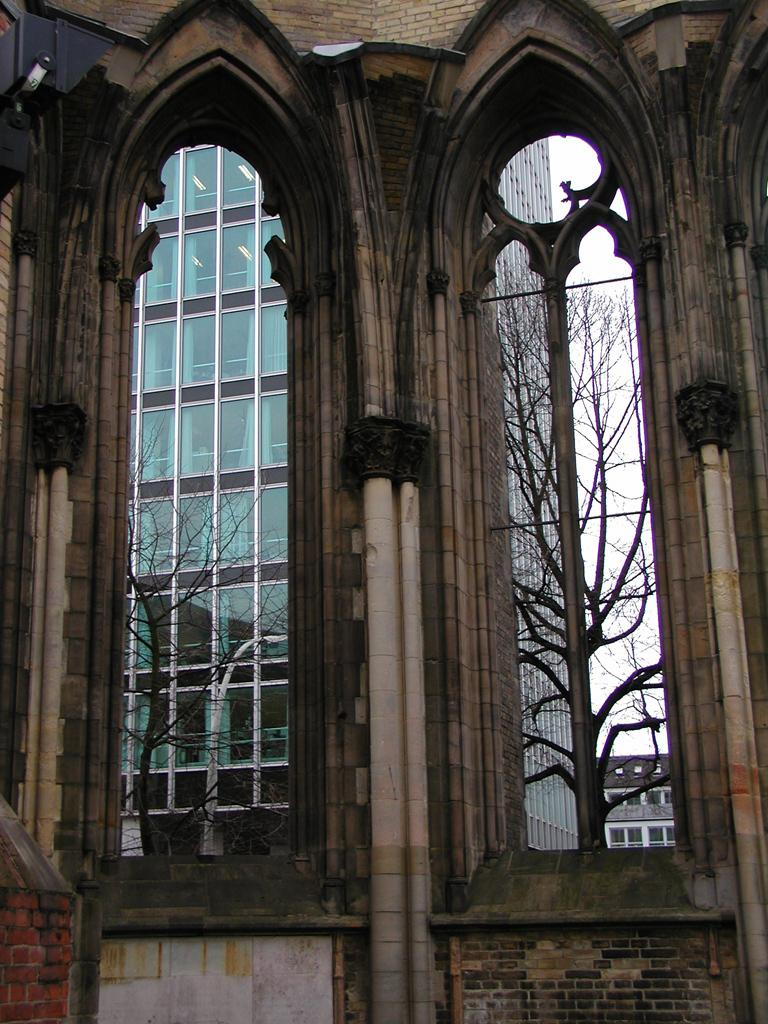What type of structure is present in the image? There is a building in the image. What feature can be seen on the building? The building has windows. What type of vegetation is visible in the image? There are dry trees in the image. What type of wall is present in the image? There is a brick wall in the image. What is the color of the sky in the image? The sky is white in color. What type of silk fabric is draped over the clock in the image? There is no clock or silk fabric present in the image. How does the steam escape from the building in the image? There is no steam present in the image. 